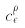<formula> <loc_0><loc_0><loc_500><loc_500>c _ { \epsilon } ^ { \rho }</formula> 